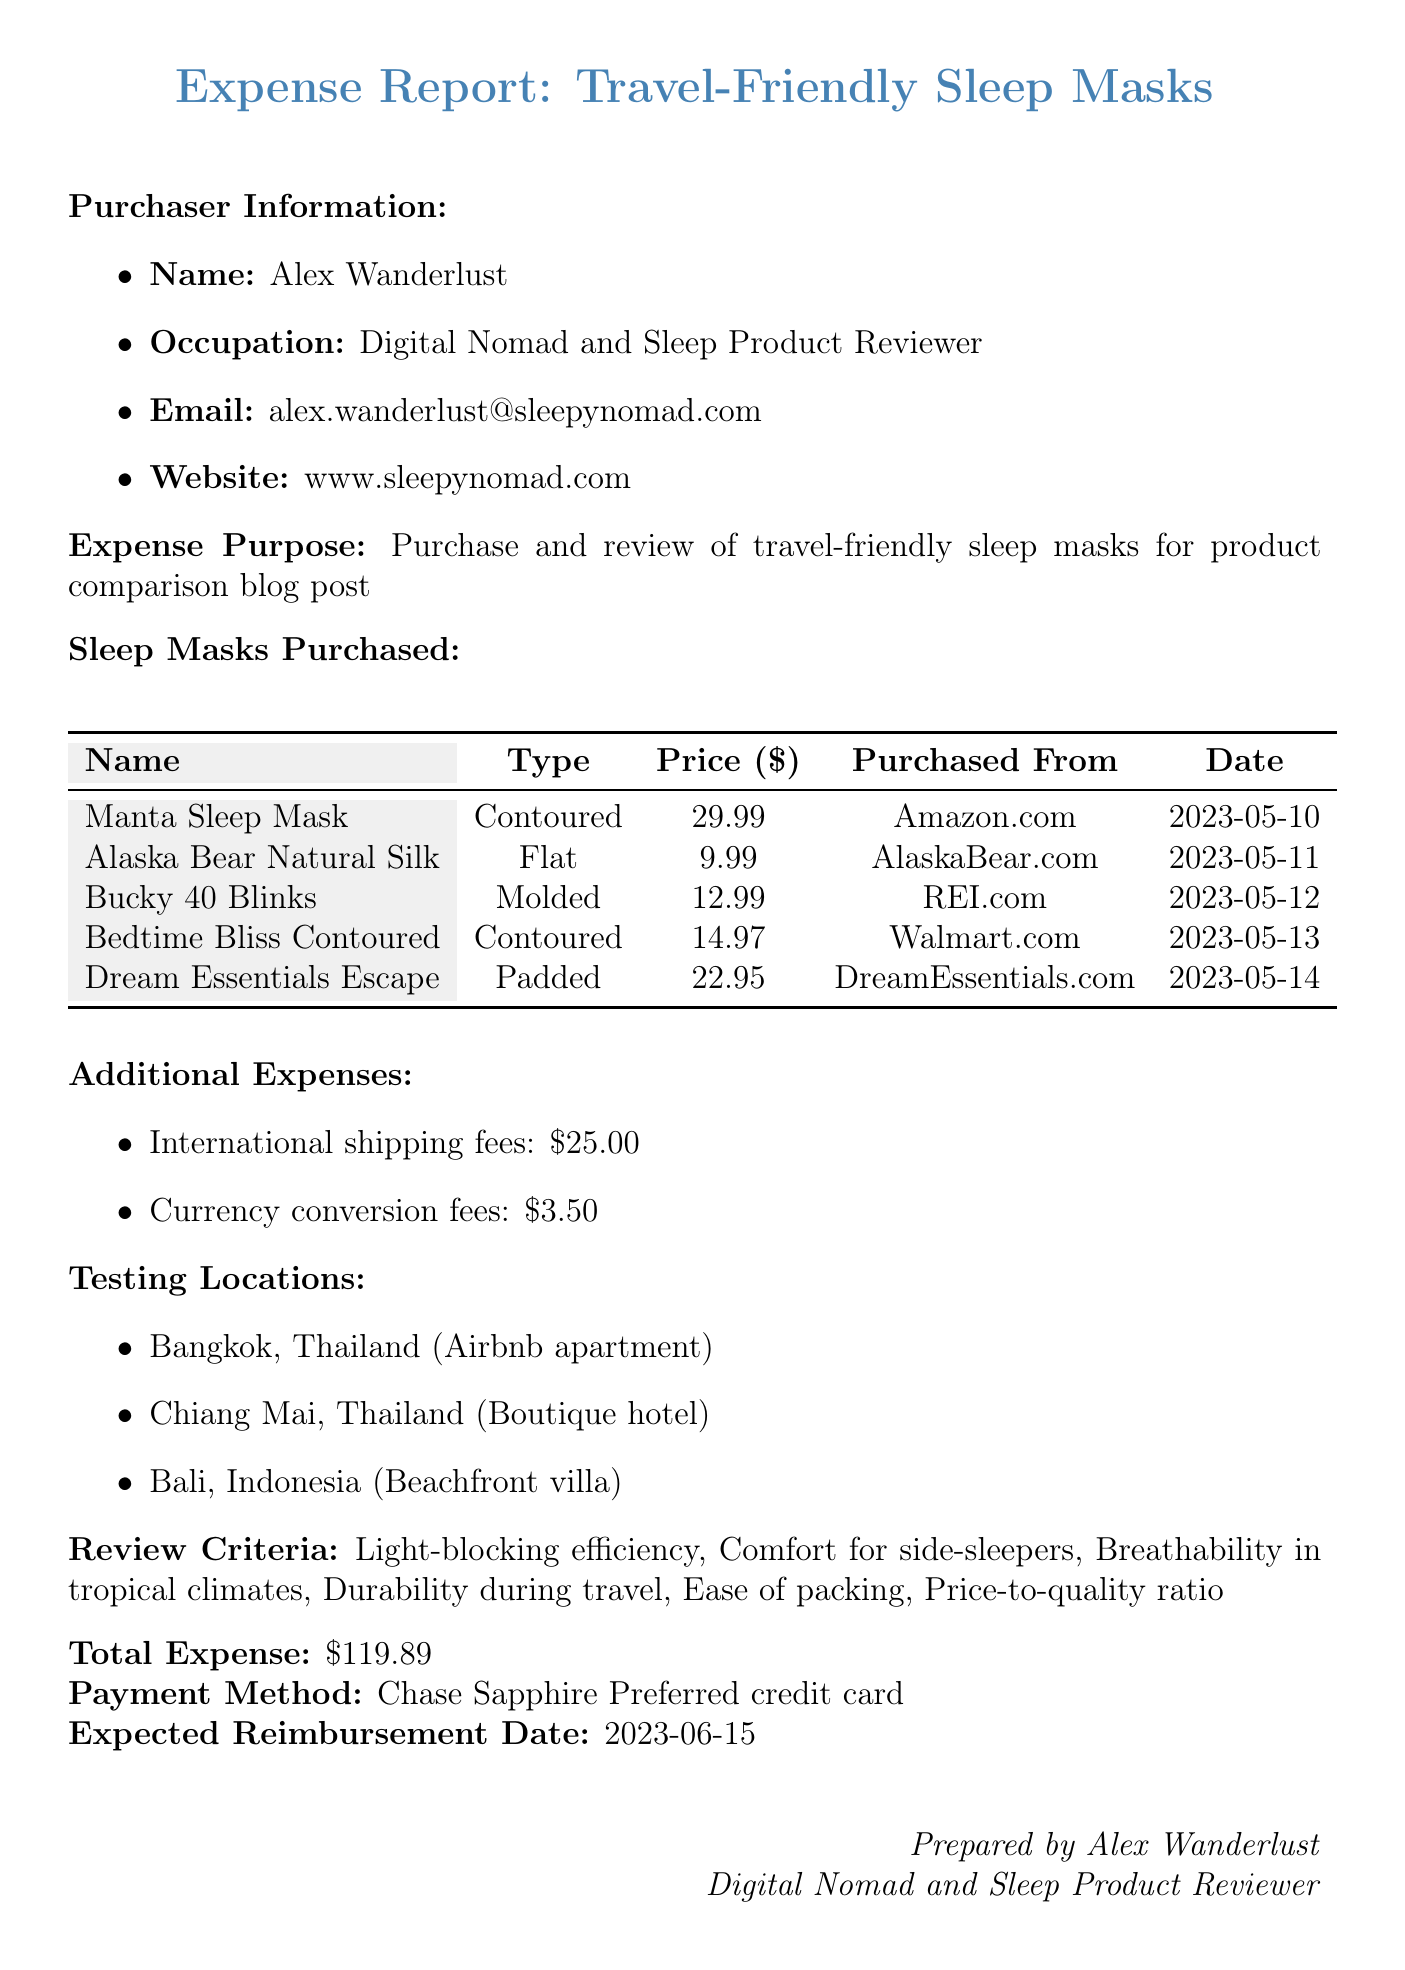What is the name of the purchaser? The document specifies that the purchaser is Alex Wanderlust.
Answer: Alex Wanderlust What is the total expense amount? The total expense is clearly stated in the document as $119.89.
Answer: $119.89 How many sleep masks were purchased? The document lists five different sleep masks purchased for review.
Answer: Five Which payment method was used for the purchases? The payment method is indicated as the Chase Sapphire Preferred credit card.
Answer: Chase Sapphire Preferred credit card What type of sleep mask is the Alaska Bear Natural Silk Sleep Mask? The type of the Alaska Bear Natural Silk Sleep Mask is specified in the table in the document as Flat.
Answer: Flat Which city was not listed as a testing location? The document mentions testing locations, and the city of Bali appears to be one of them; Bangkok and Chiang Mai are also listed, making them definable. Hence, any city not mentioned is the one left out.
Answer: None What was the purchase date of the Manta Sleep Mask? The document provides the purchase date, which is May 10, 2023, for the Manta Sleep Mask.
Answer: 2023-05-10 What is the purpose of the expenses? The purpose of these expenses is to purchase and review travel-friendly sleep masks for a blog post.
Answer: Purchase and review of travel-friendly sleep masks for product comparison blog post What is the expected reimbursement date? The document specifies that the expected reimbursement date is June 15, 2023.
Answer: 2023-06-15 